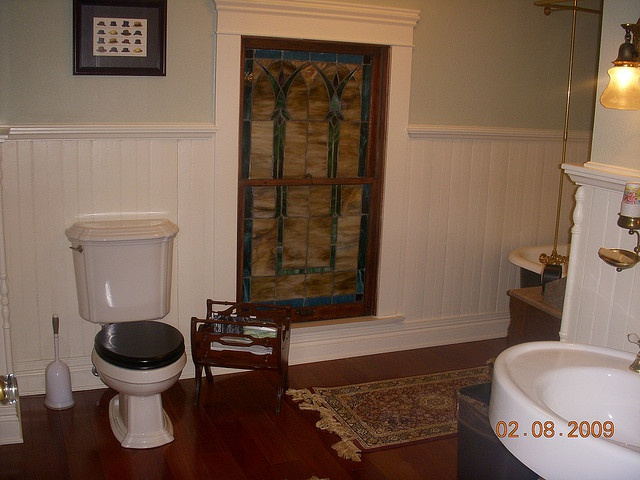Describe the objects in this image and their specific colors. I can see toilet in gray and black tones and sink in gray, darkgray, and lightgray tones in this image. 